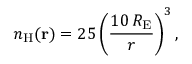<formula> <loc_0><loc_0><loc_500><loc_500>n _ { H } ( r ) = 2 5 \left ( \frac { 1 0 \, R _ { E } } { r } \right ) ^ { 3 } ,</formula> 